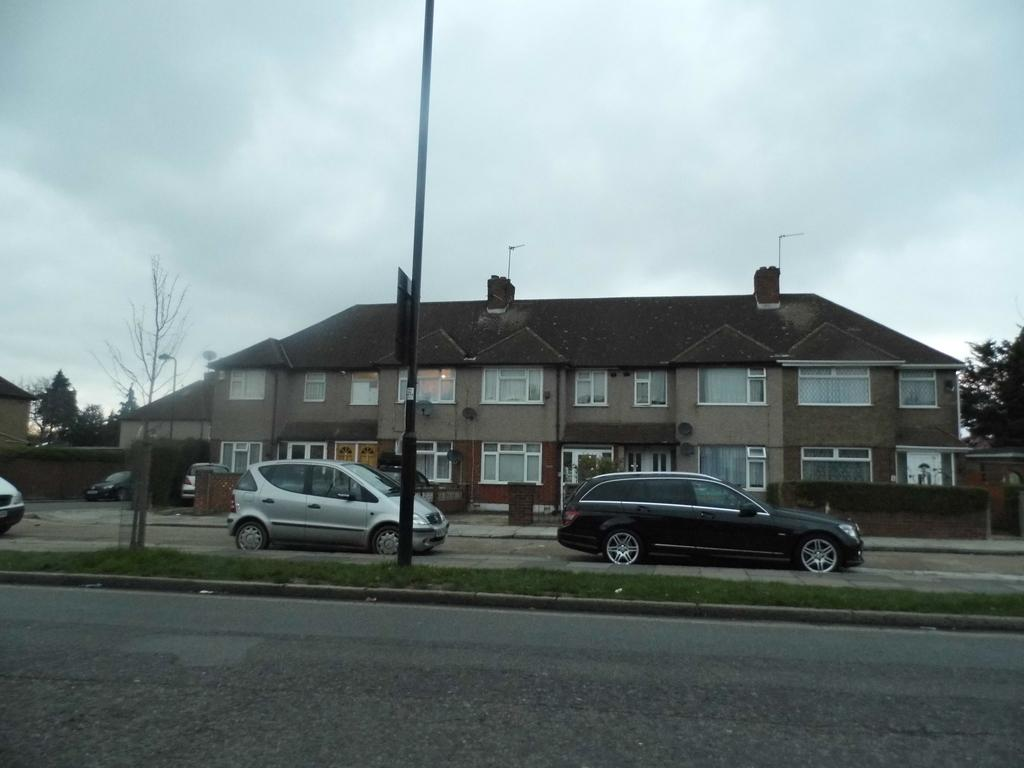What can be seen on the road in the image? There are cars on the road in the image. What is the board in the image used for? The purpose of the board in the image is not specified, but it could be a sign or advertisement. What is the pole in the image used for? The pole in the image could be used for various purposes, such as supporting a sign, street light, or electrical wires. What type of vegetation is present in the image? There are trees in the image. What type of structures can be seen in the image? There are houses and a wall in the image. What is visible in the background of the image? The sky is visible in the background of the image, and it appears to be cloudy. What type of coat is hanging on the wall in the image? There is no coat present in the image; only a wall is visible. What is the current temperature in the image? The image does not provide information about the temperature; it only shows a cloudy sky in the background. 